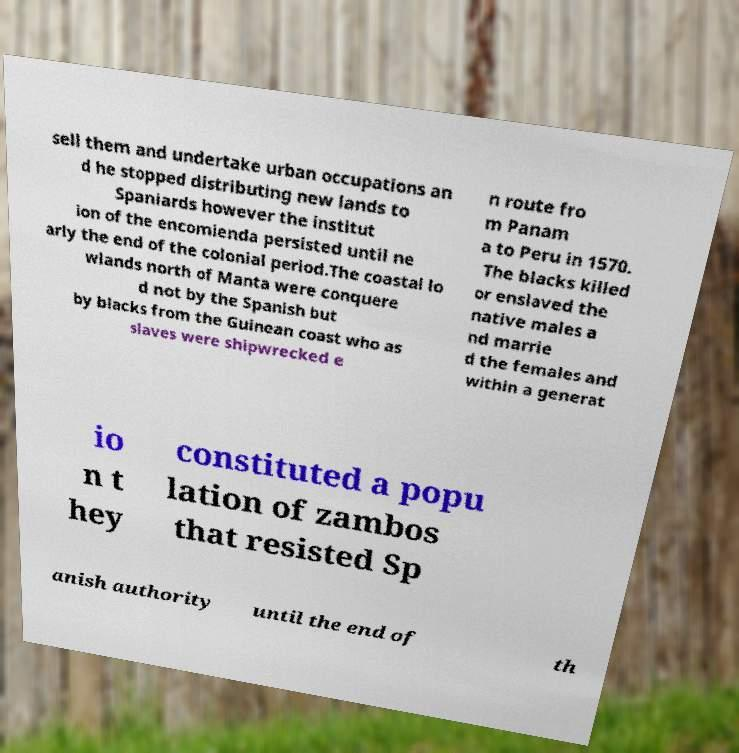Could you assist in decoding the text presented in this image and type it out clearly? sell them and undertake urban occupations an d he stopped distributing new lands to Spaniards however the institut ion of the encomienda persisted until ne arly the end of the colonial period.The coastal lo wlands north of Manta were conquere d not by the Spanish but by blacks from the Guinean coast who as slaves were shipwrecked e n route fro m Panam a to Peru in 1570. The blacks killed or enslaved the native males a nd marrie d the females and within a generat io n t hey constituted a popu lation of zambos that resisted Sp anish authority until the end of th 